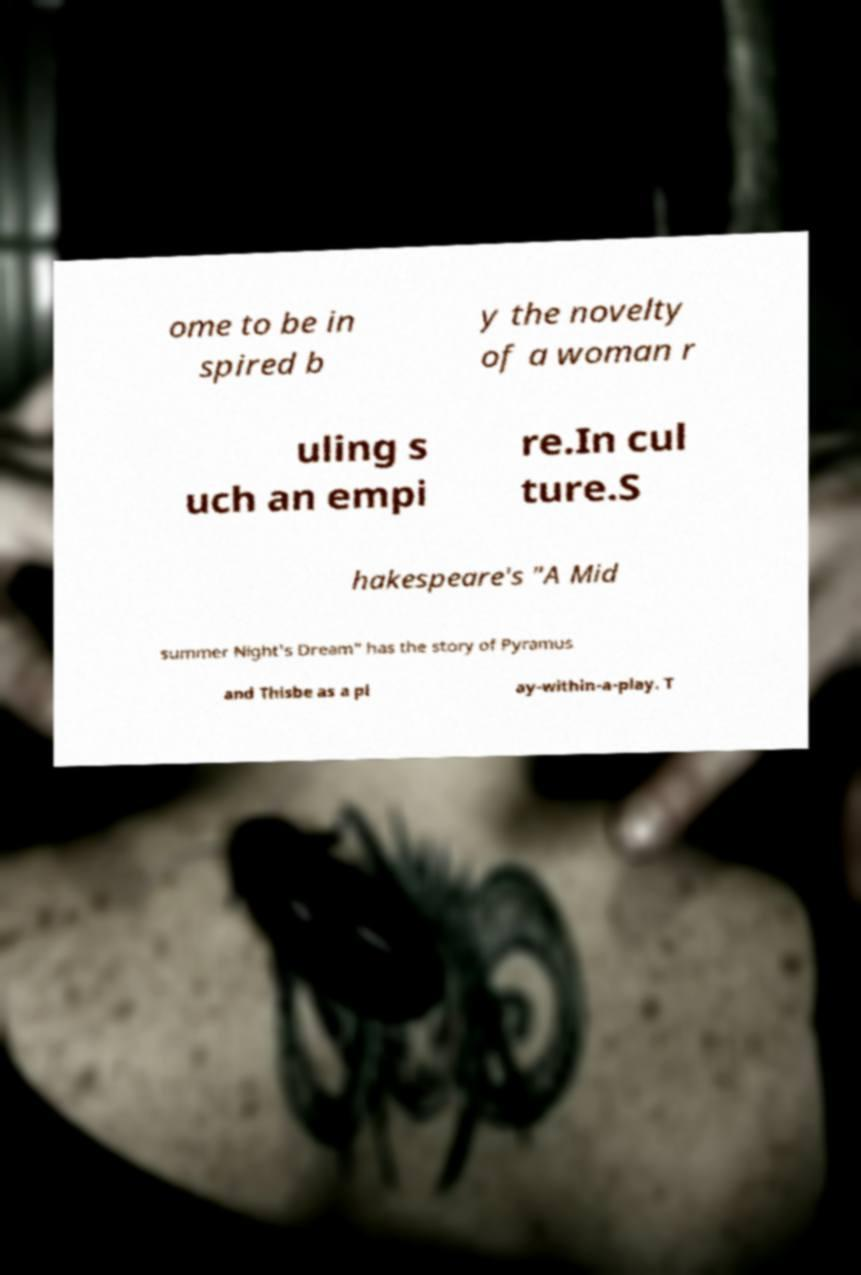What messages or text are displayed in this image? I need them in a readable, typed format. ome to be in spired b y the novelty of a woman r uling s uch an empi re.In cul ture.S hakespeare's "A Mid summer Night's Dream" has the story of Pyramus and Thisbe as a pl ay-within-a-play. T 